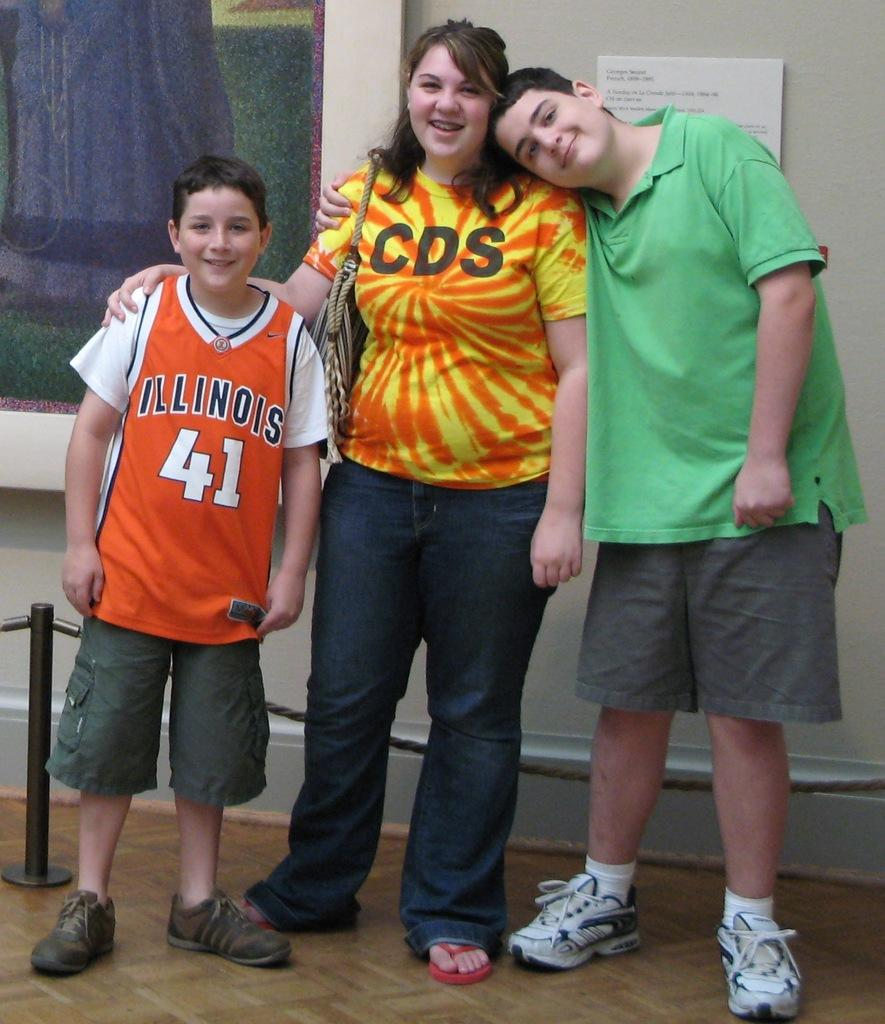<image>
Offer a succinct explanation of the picture presented. two young boys and one woman wearing a t-shirt with "CDS" logo posing for a photo in an art museum. 